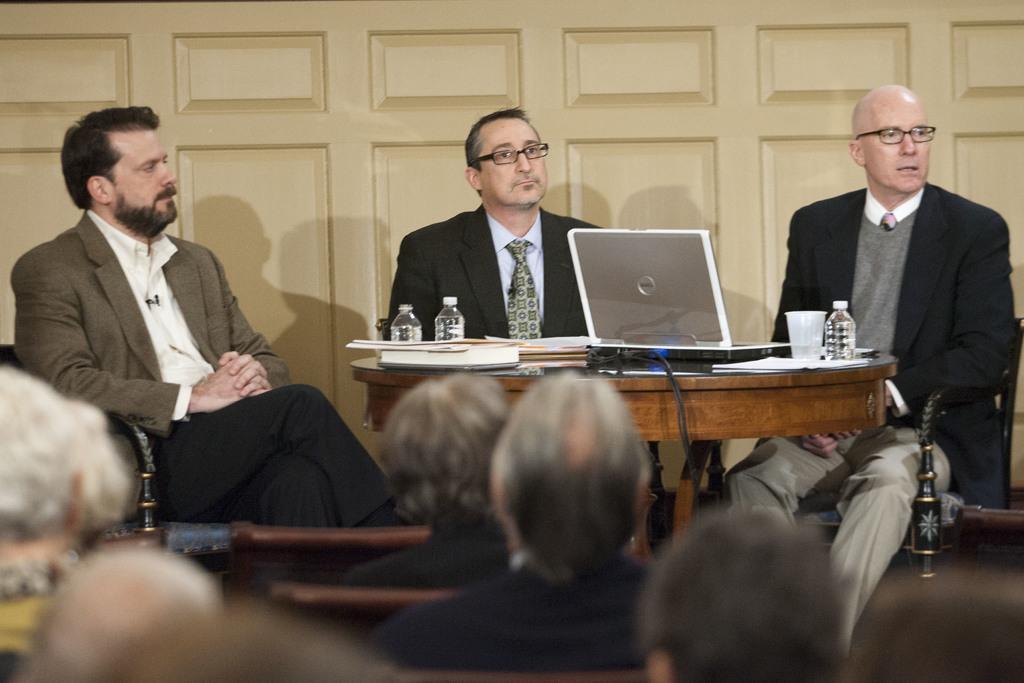Describe this image in one or two sentences. In this image I can see people sitting at the front. There is a table on which there is a laptop, glass, books and bottles. Few people are seated at the back. 